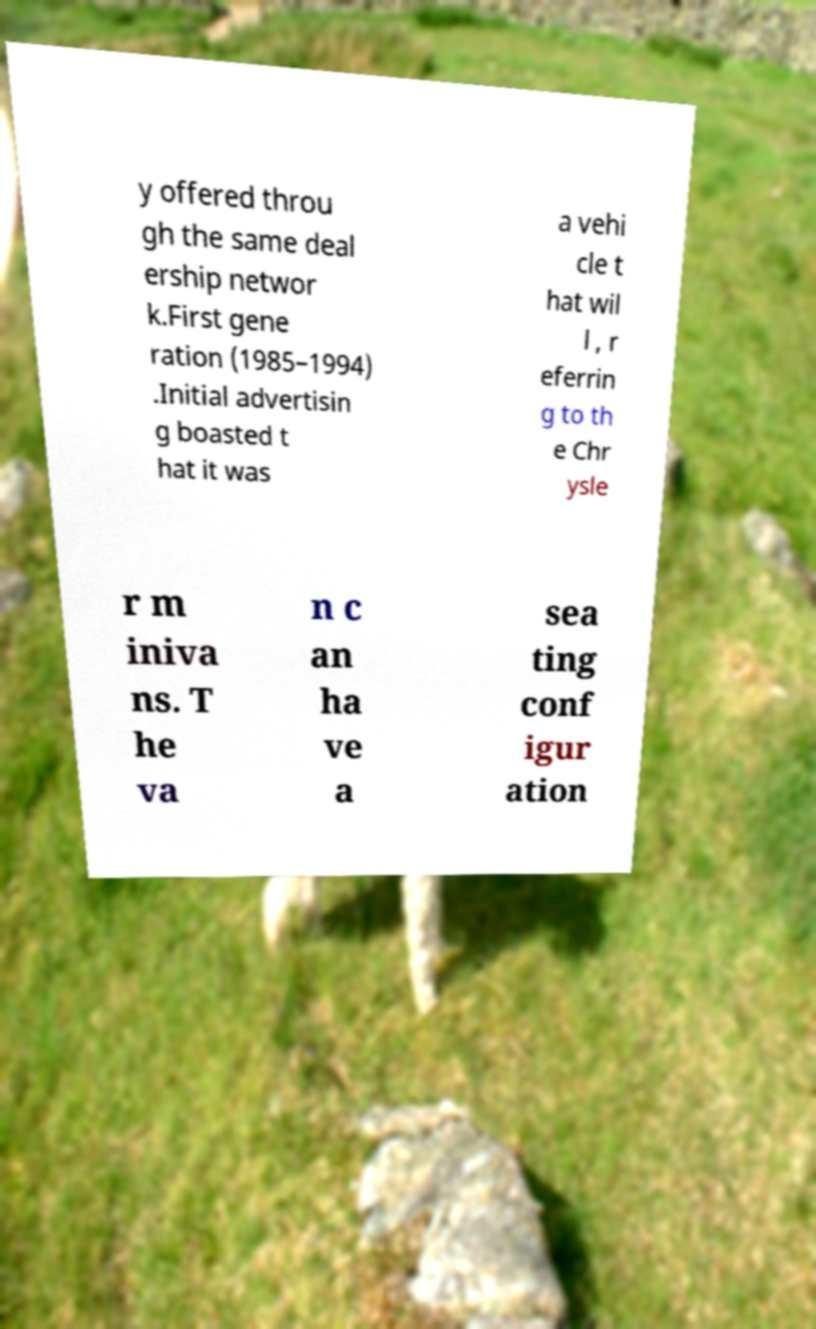I need the written content from this picture converted into text. Can you do that? y offered throu gh the same deal ership networ k.First gene ration (1985–1994) .Initial advertisin g boasted t hat it was a vehi cle t hat wil l , r eferrin g to th e Chr ysle r m iniva ns. T he va n c an ha ve a sea ting conf igur ation 